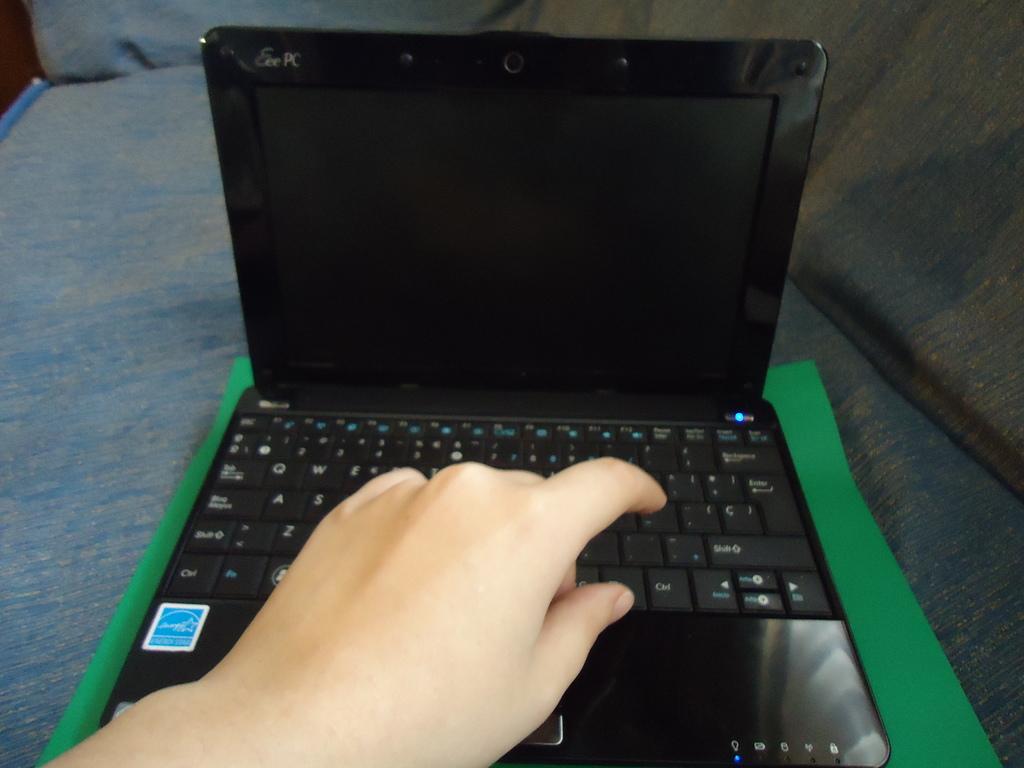What is the wide narrow key to the right of the index finger?
Ensure brevity in your answer.  Shift. 